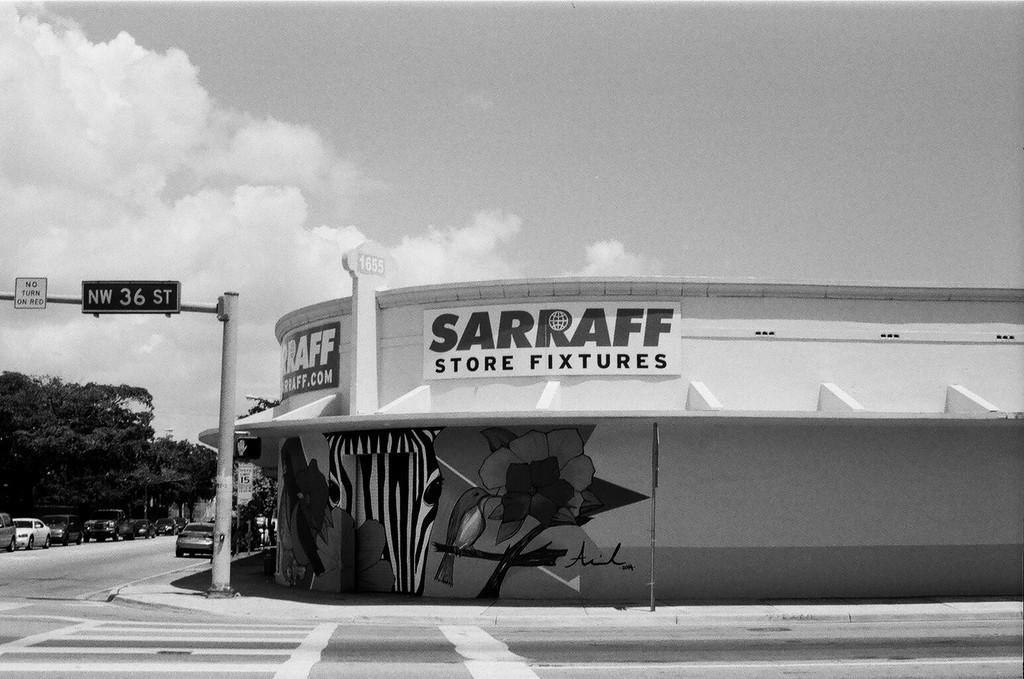Describe this image in one or two sentences. This is a black and white image. I can see a building with the name boards attached to it. These are the boards attached to a pole. I can see the cars on the road. These are the trees. I can see the clouds in the sky. 